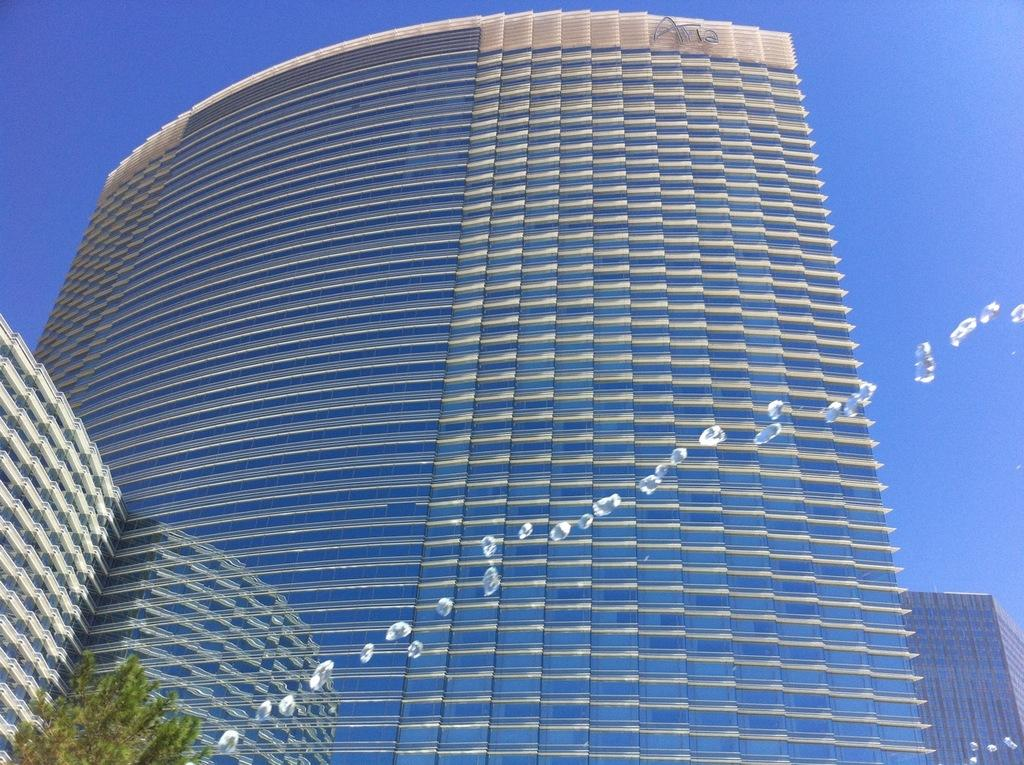What structures are visible in the image? There are buildings in the image. What type of vegetation is present in the image? There are trees in the image. What part of the natural environment is visible in the image? The sky is visible in the image. Can you tell me how many turkeys are sitting in the crib in the image? There are no turkeys or cribs present in the image; it features buildings, trees, and the sky. What type of creature is shown interacting with the thumb in the image? There is no creature shown interacting with a thumb in the image; it only features buildings, trees, and the sky. 